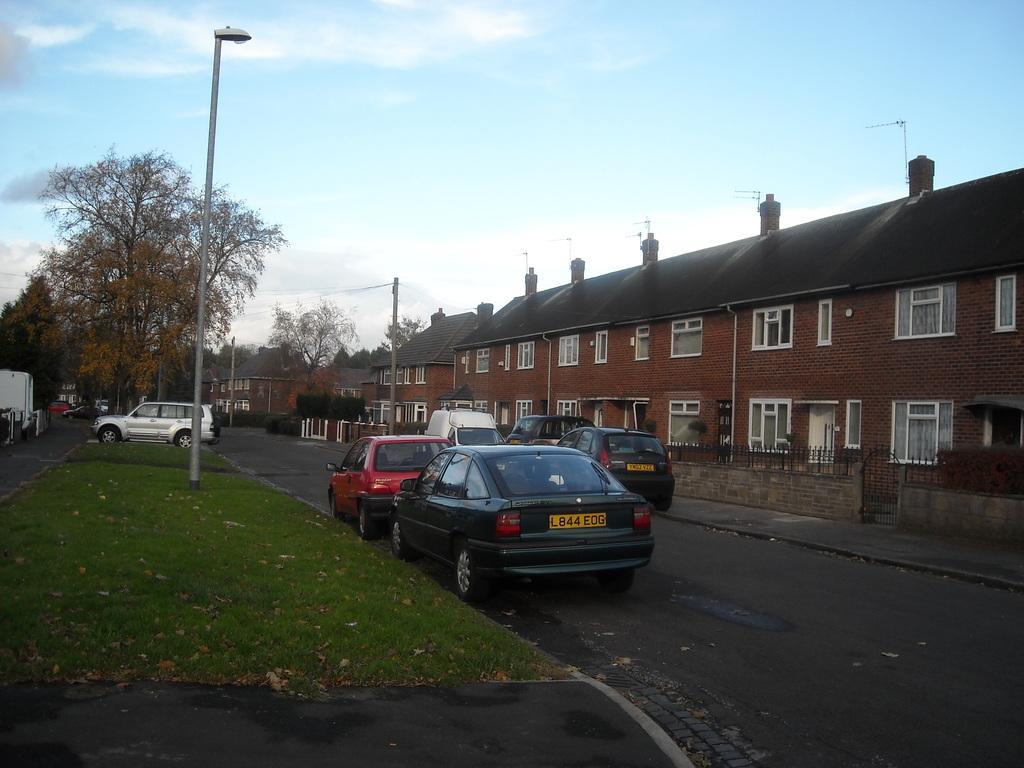Please provide a concise description of this image. On the left side there is a grass lawn with a street light pole. Also there is a car and trees. On the right side there is a building with windows and there is a wall with railings. Near to that there is a sidewalk. On the road there are cars. In the background there is sky, trees and buildings. On the left side there is a grass lawn with street light pole. In the background there is sky, trees and buildings. 